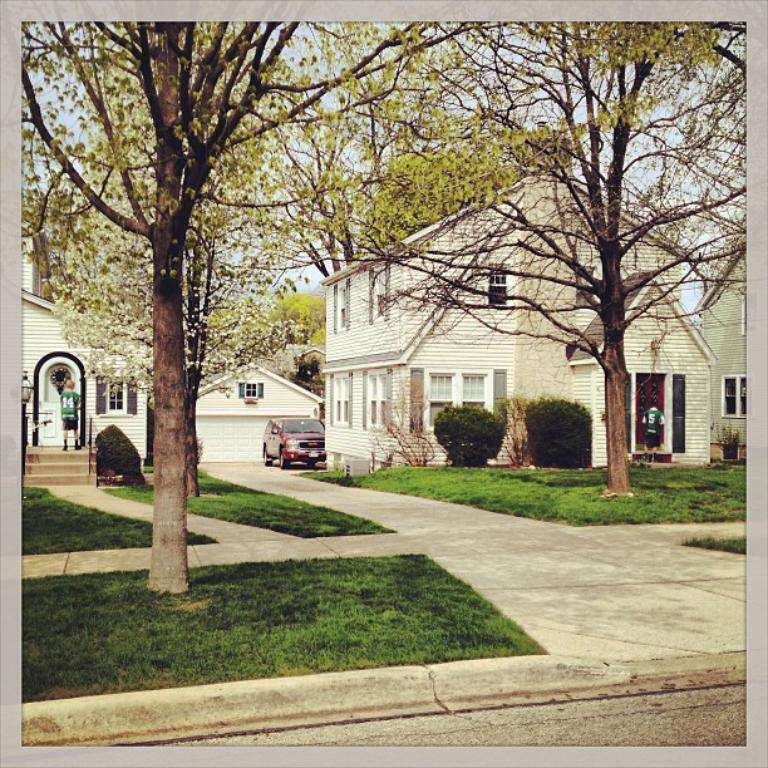What type of structures can be seen in the image? There are buildings in the image. What else is present in the image besides the buildings? There are persons standing, a motor vehicle, bushes, trees, and the sky is visible in the image. What language is being spoken by the persons in the image? There is no indication of any language being spoken in the image, as it only shows visual elements. 